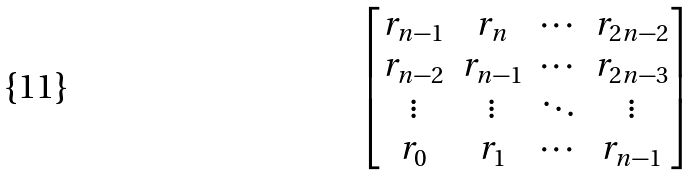<formula> <loc_0><loc_0><loc_500><loc_500>\begin{bmatrix} r _ { n - 1 } & r _ { n } & \cdots & r _ { 2 n - 2 } \\ r _ { n - 2 } & r _ { n - 1 } & \cdots & r _ { 2 n - 3 } \\ \vdots & \vdots & \ddots & \vdots \\ r _ { 0 } & r _ { 1 } & \cdots & r _ { n - 1 } \end{bmatrix}</formula> 